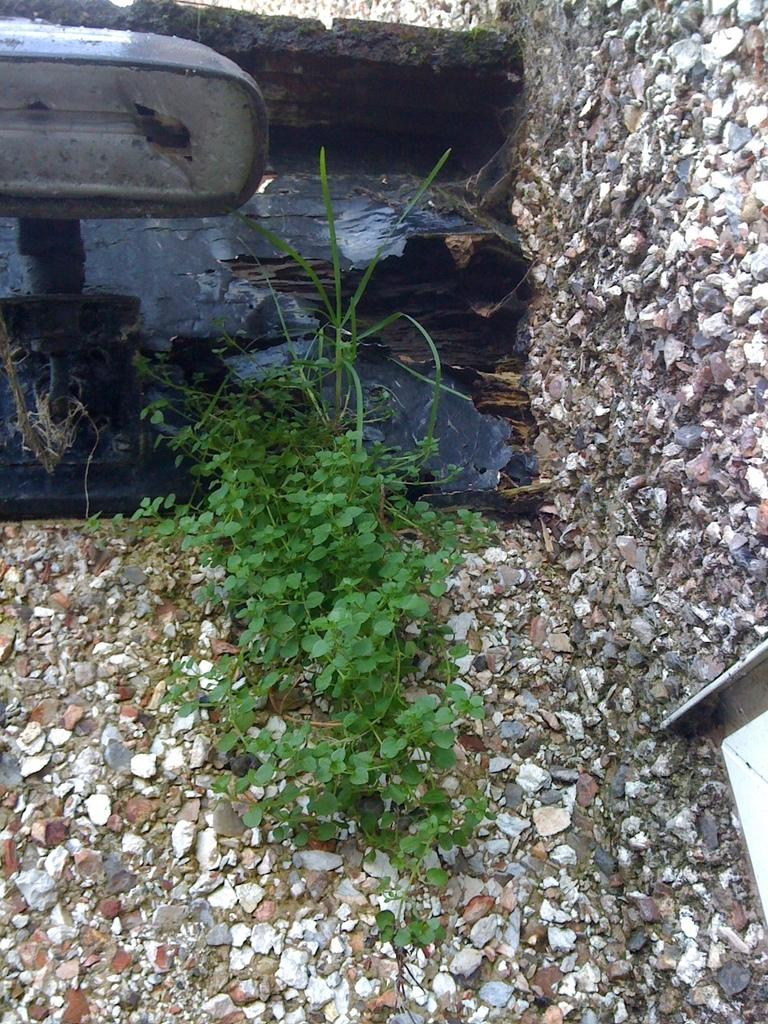What type of living organism can be seen in the image? There is a plant in the image. What inorganic objects are present in the image? There are stones in the image. Can you describe the object in the image? Unfortunately, the facts provided do not give enough information to describe the object in the image. What type of protest is taking place in the image? There is no protest present in the image. How many hands can be seen interacting with the plant in the image? There is no information about hands or any interaction with the plant in the image. 